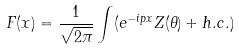<formula> <loc_0><loc_0><loc_500><loc_500>F ( x ) = \frac { 1 } { \sqrt { 2 \pi } } \int ( e ^ { - i p x } Z ( \theta ) + h . c . )</formula> 